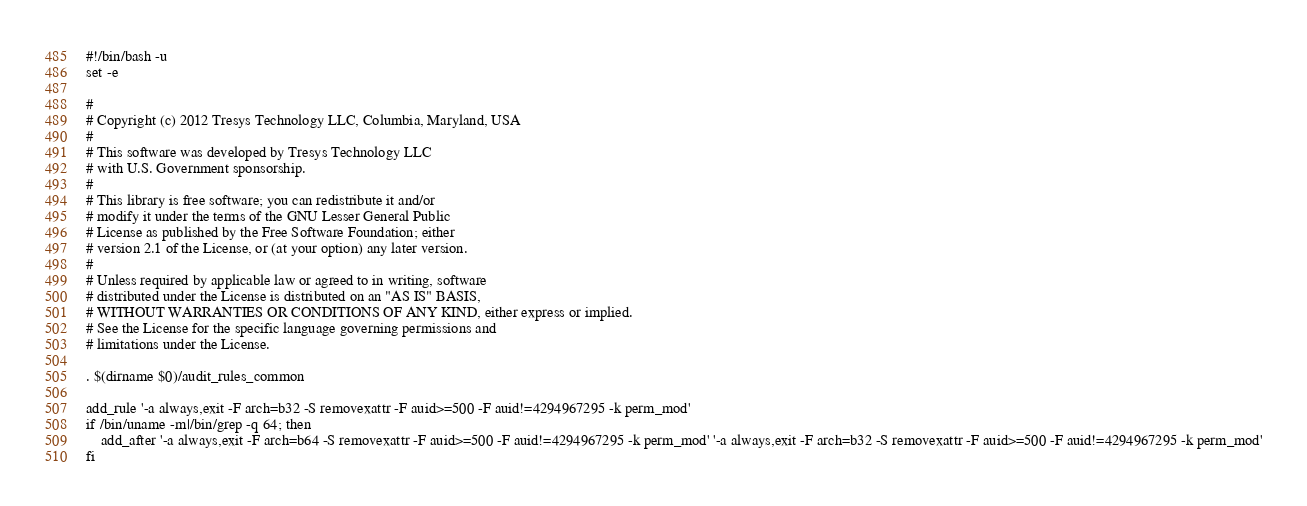<code> <loc_0><loc_0><loc_500><loc_500><_Bash_>#!/bin/bash -u
set -e

# 
# Copyright (c) 2012 Tresys Technology LLC, Columbia, Maryland, USA
#
# This software was developed by Tresys Technology LLC
# with U.S. Government sponsorship.
#
# This library is free software; you can redistribute it and/or
# modify it under the terms of the GNU Lesser General Public
# License as published by the Free Software Foundation; either
# version 2.1 of the License, or (at your option) any later version.
#
# Unless required by applicable law or agreed to in writing, software
# distributed under the License is distributed on an "AS IS" BASIS,
# WITHOUT WARRANTIES OR CONDITIONS OF ANY KIND, either express or implied.
# See the License for the specific language governing permissions and
# limitations under the License.

. $(dirname $0)/audit_rules_common

add_rule '-a always,exit -F arch=b32 -S removexattr -F auid>=500 -F auid!=4294967295 -k perm_mod'
if /bin/uname -m|/bin/grep -q 64; then
	add_after '-a always,exit -F arch=b64 -S removexattr -F auid>=500 -F auid!=4294967295 -k perm_mod' '-a always,exit -F arch=b32 -S removexattr -F auid>=500 -F auid!=4294967295 -k perm_mod'
fi
</code> 